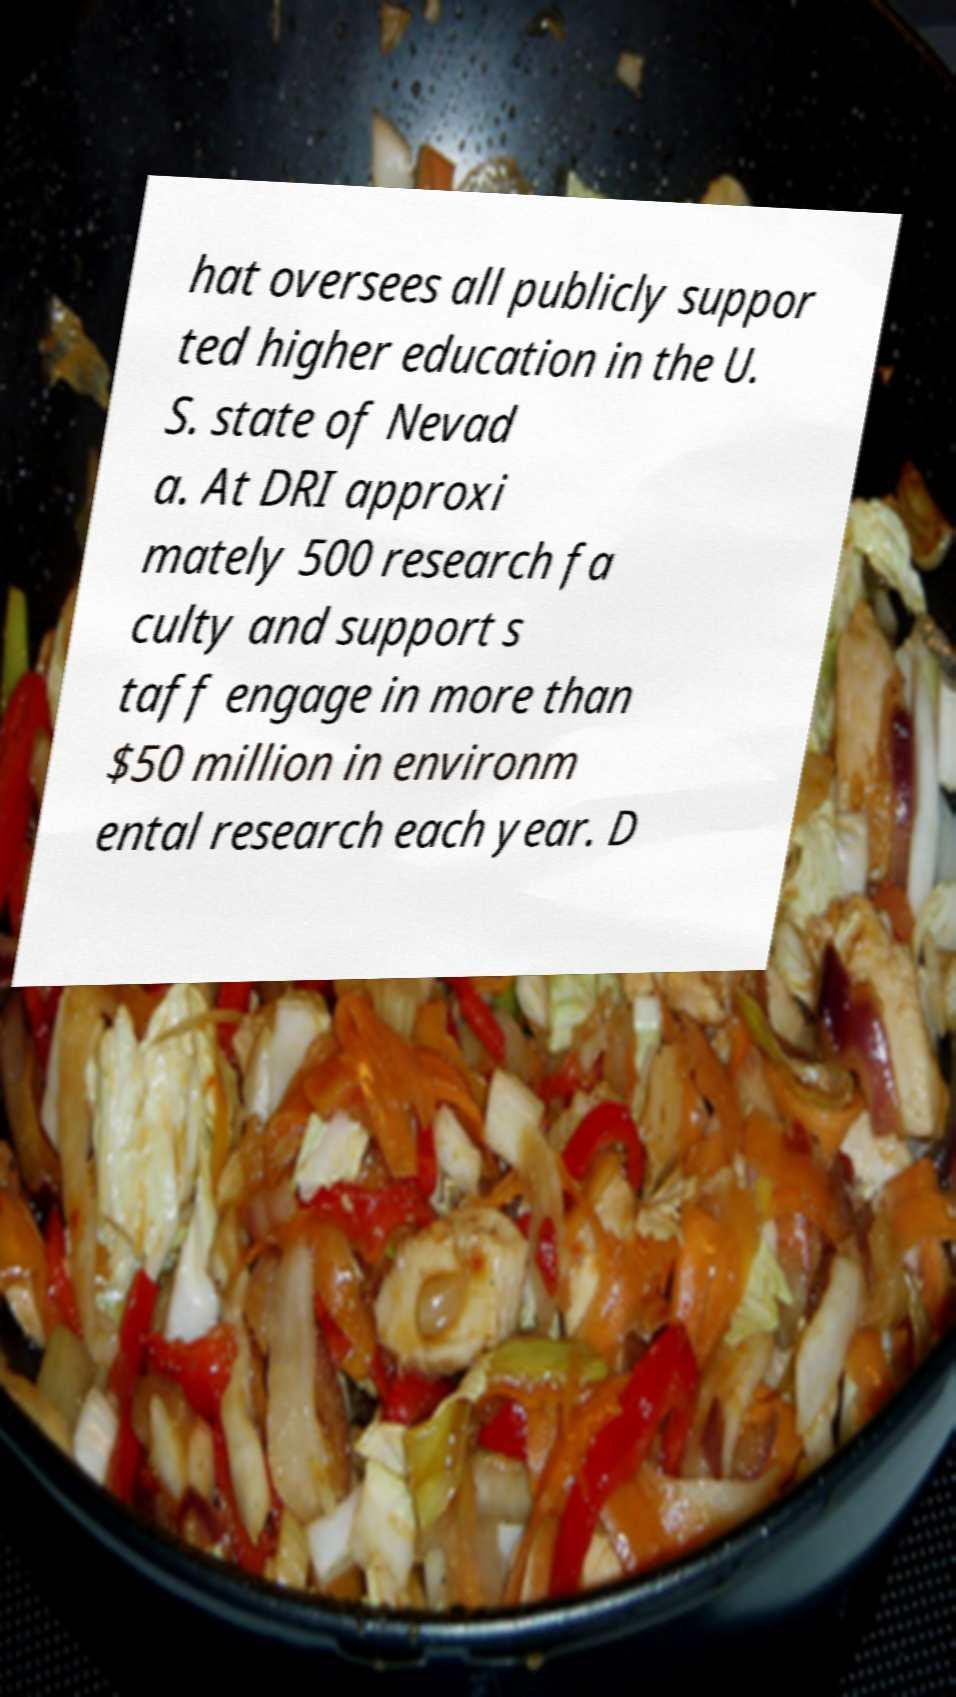Can you read and provide the text displayed in the image?This photo seems to have some interesting text. Can you extract and type it out for me? hat oversees all publicly suppor ted higher education in the U. S. state of Nevad a. At DRI approxi mately 500 research fa culty and support s taff engage in more than $50 million in environm ental research each year. D 